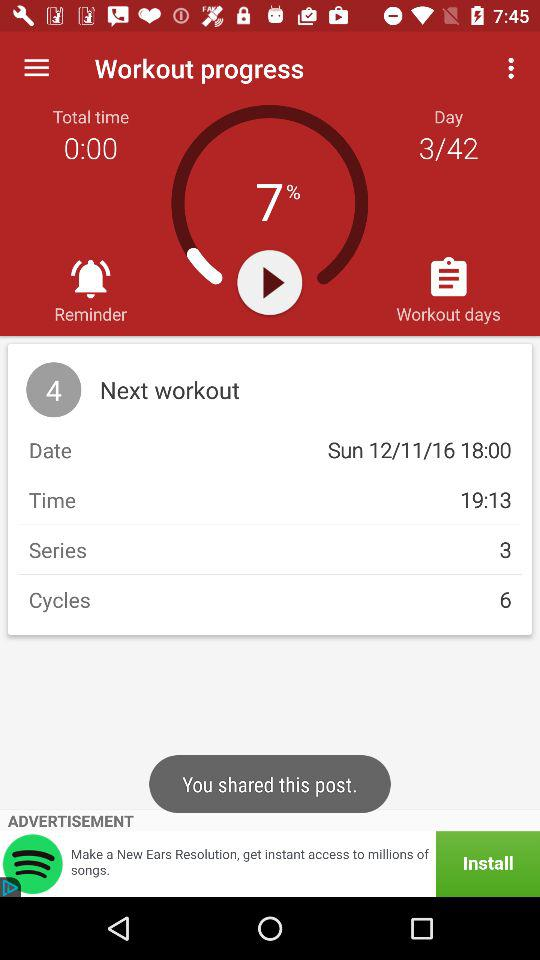What is the time for the next workout? The time for the next workout is 19:13. 